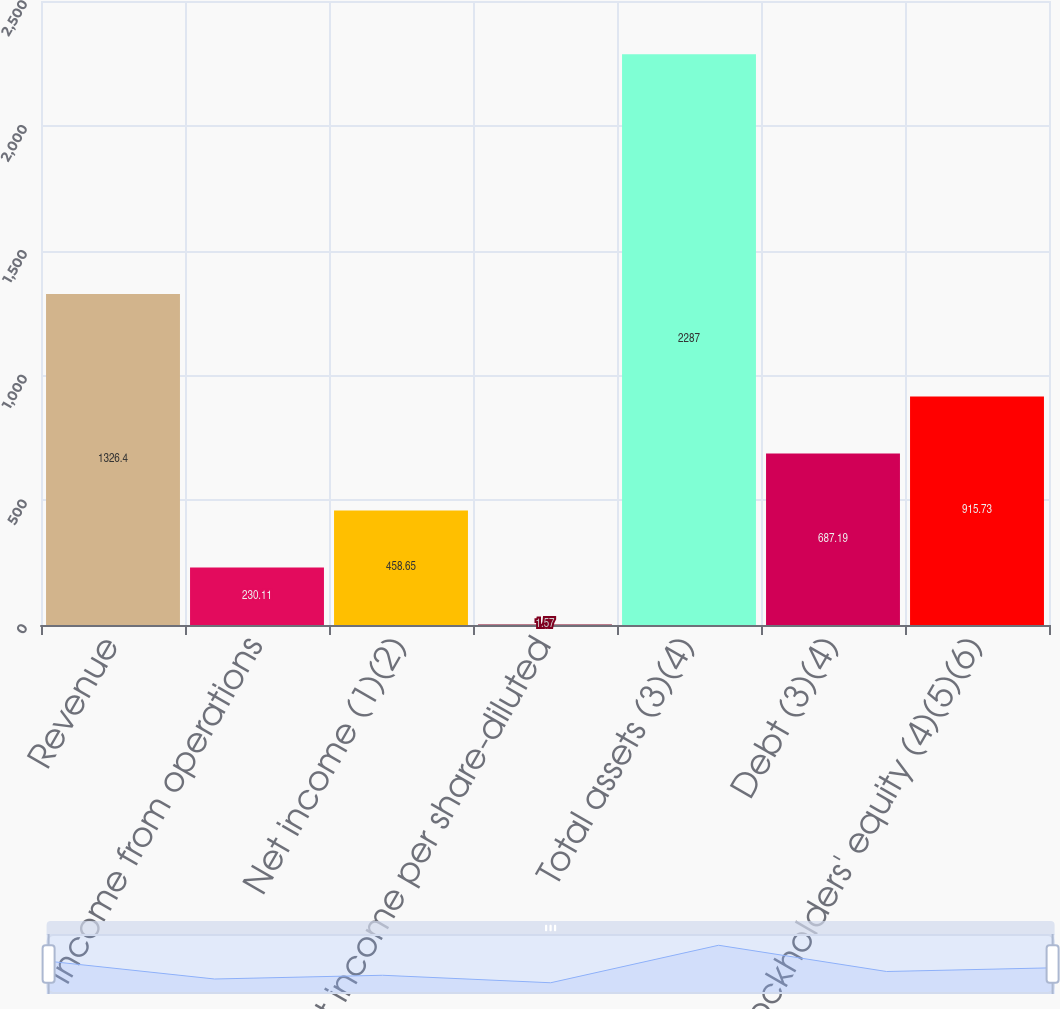Convert chart. <chart><loc_0><loc_0><loc_500><loc_500><bar_chart><fcel>Revenue<fcel>Income from operations<fcel>Net income (1)(2)<fcel>Net income per share-diluted<fcel>Total assets (3)(4)<fcel>Debt (3)(4)<fcel>Stockholders' equity (4)(5)(6)<nl><fcel>1326.4<fcel>230.11<fcel>458.65<fcel>1.57<fcel>2287<fcel>687.19<fcel>915.73<nl></chart> 